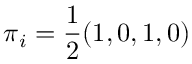<formula> <loc_0><loc_0><loc_500><loc_500>\pi _ { i } = \frac { 1 } { 2 } ( 1 , 0 , 1 , 0 )</formula> 